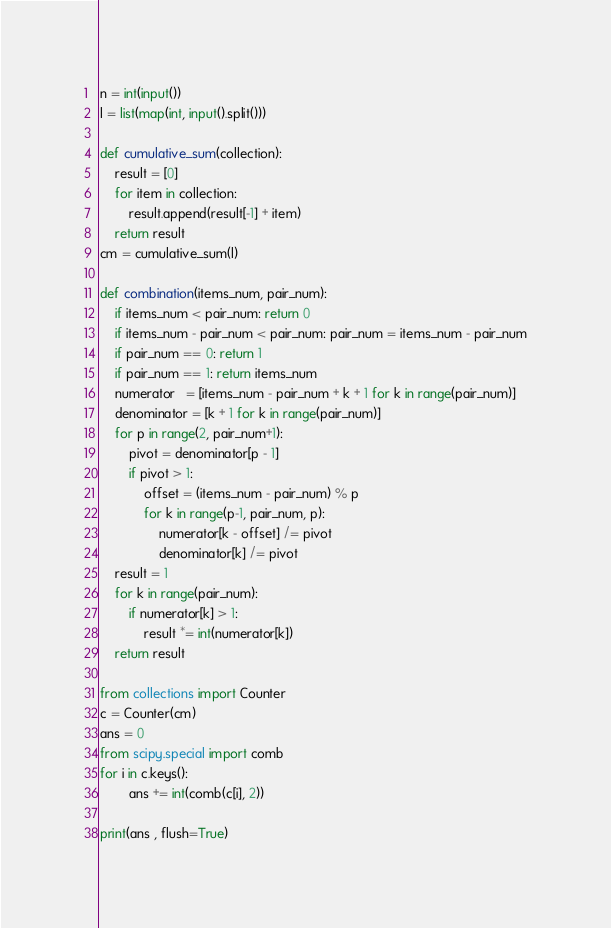Convert code to text. <code><loc_0><loc_0><loc_500><loc_500><_Python_>n = int(input())
l = list(map(int, input().split()))

def cumulative_sum(collection):
    result = [0]
    for item in collection:
        result.append(result[-1] + item)
    return result
cm = cumulative_sum(l)

def combination(items_num, pair_num):
    if items_num < pair_num: return 0
    if items_num - pair_num < pair_num: pair_num = items_num - pair_num
    if pair_num == 0: return 1
    if pair_num == 1: return items_num
    numerator   = [items_num - pair_num + k + 1 for k in range(pair_num)]
    denominator = [k + 1 for k in range(pair_num)]
    for p in range(2, pair_num+1):
        pivot = denominator[p - 1]
        if pivot > 1:
            offset = (items_num - pair_num) % p
            for k in range(p-1, pair_num, p):
                numerator[k - offset] /= pivot
                denominator[k] /= pivot
    result = 1
    for k in range(pair_num):
        if numerator[k] > 1:
            result *= int(numerator[k])
    return result

from collections import Counter
c = Counter(cm)
ans = 0
from scipy.special import comb
for i in c.keys():
        ans += int(comb(c[i], 2))

print(ans , flush=True)
</code> 